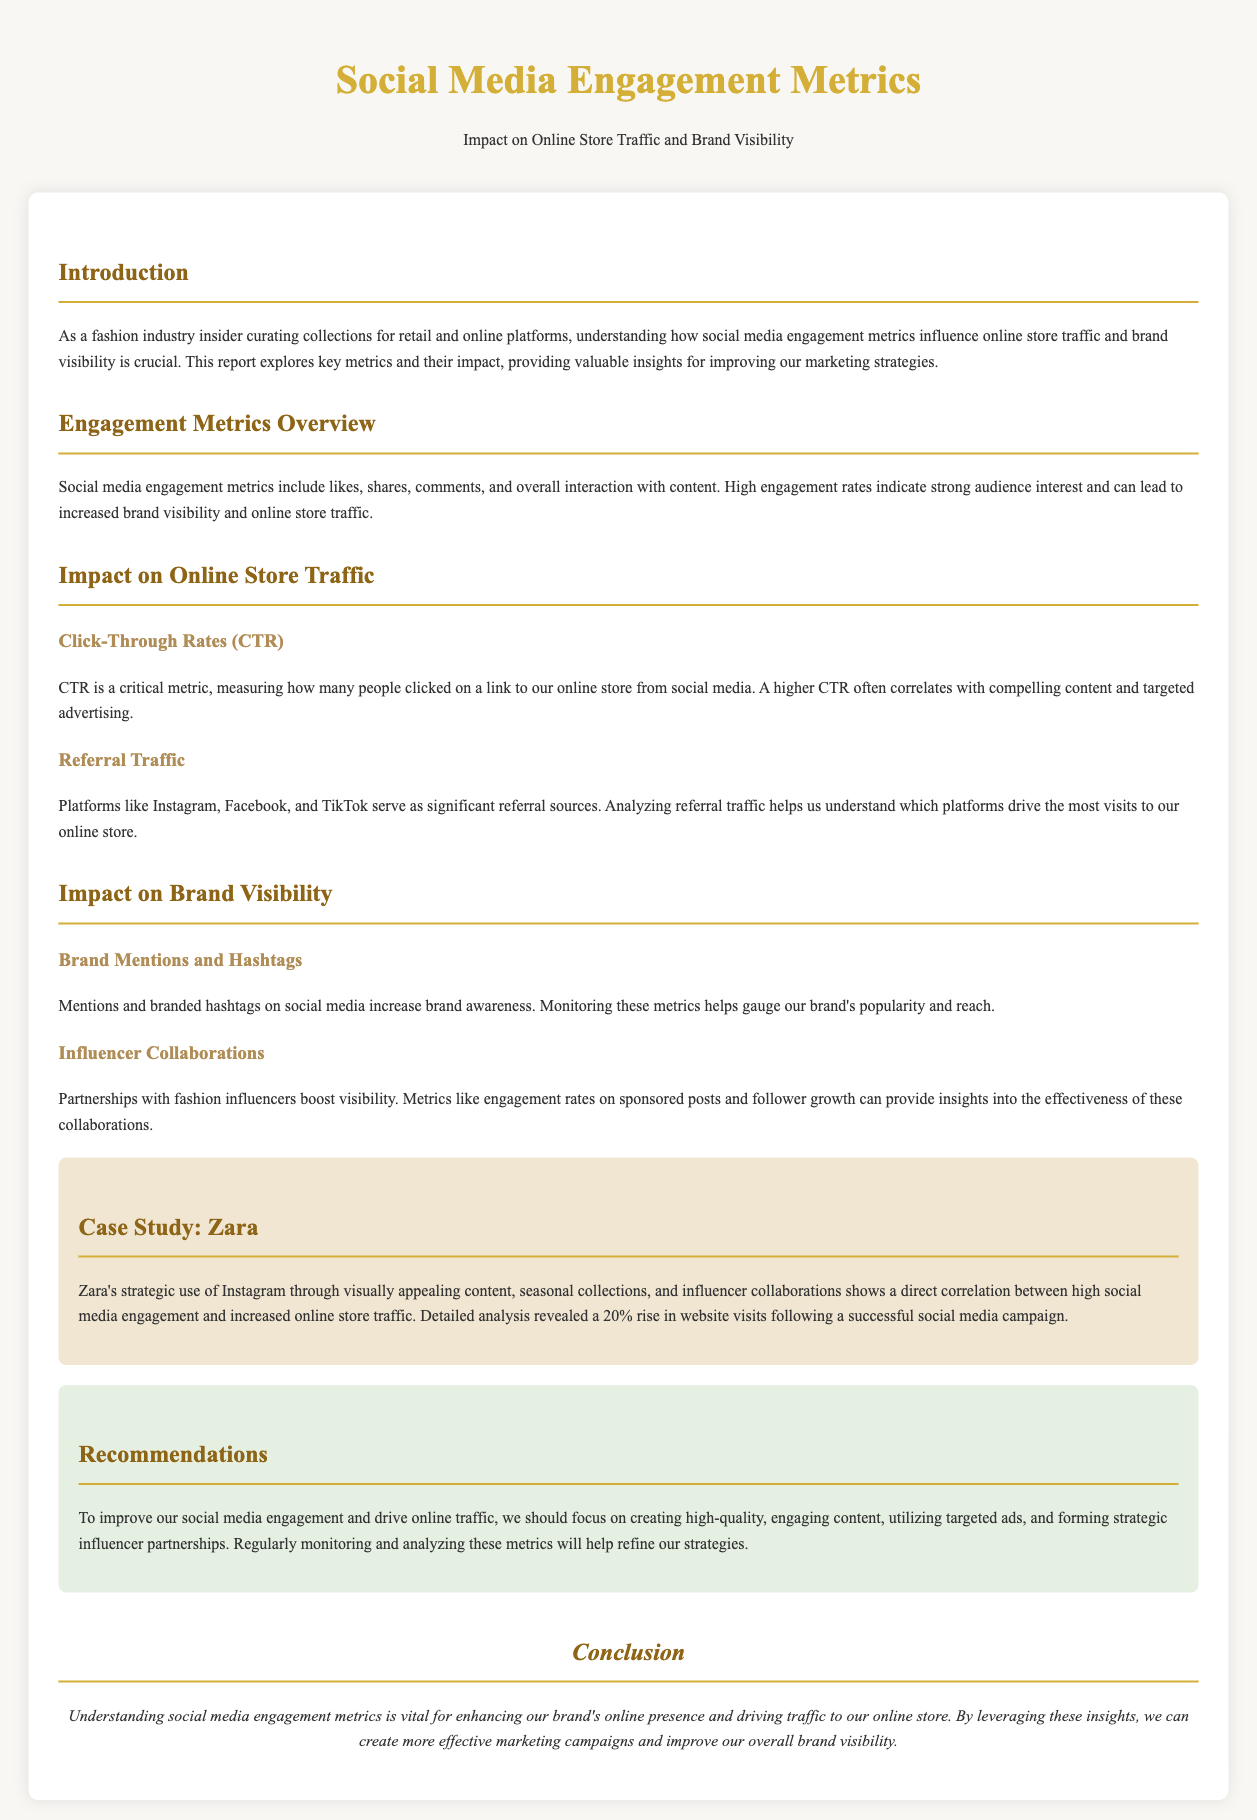What is the main focus of the report? The report focuses on understanding how social media engagement metrics influence online store traffic and brand visibility.
Answer: Social media engagement metrics What does CTR stand for? CTR is defined in the document as Click-Through Rates, measuring clicks to our online store from social media.
Answer: Click-Through Rates What was the percentage increase in website visits for Zara? The case study mentions a 20% rise in website visits following a successful social media campaign.
Answer: 20% What type of content does Zara utilize on Instagram? The document mentions that Zara uses visually appealing content for their Instagram strategy.
Answer: Visually appealing content Which platforms are significant for referral traffic? The document lists Instagram, Facebook, and TikTok as significant sources of referral traffic.
Answer: Instagram, Facebook, TikTok What is one recommendation for improving social media engagement? The report recommends focusing on creating high-quality, engaging content.
Answer: Creating high-quality, engaging content What type of collaborations boost brand visibility? Partnerships with fashion influencers are indicated as effective in boosting visibility.
Answer: Influencer collaborations What is the font style used in the document? The document specifies 'Playfair Display' as the font style used.
Answer: Playfair Display 